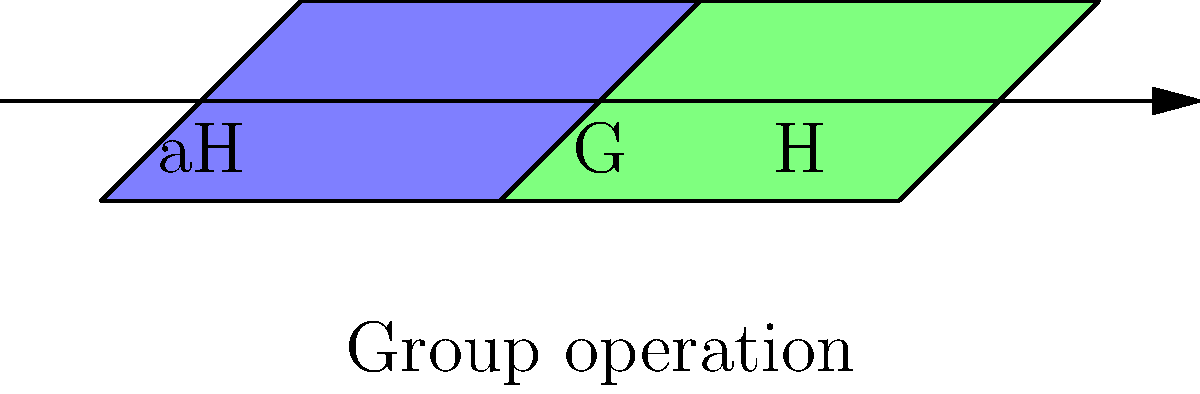In the context of group theory, consider a group $G$ represented by the entire diagram, with a subgroup $H$ (green region) and a coset $aH$ (blue region). How does this visual representation relate to the concept of cosets, and what implications does it have for understanding the structure of the group $G$? To understand the concept of cosets and its implications for the group structure, let's break it down step-by-step:

1. Group $G$: The entire diagram represents the group $G$, which contains all elements of the group.

2. Subgroup $H$: The green region represents a subgroup $H$ of $G$. A subgroup is a subset of $G$ that is itself a group under the same operation.

3. Coset $aH$: The blue region represents a left coset $aH$, where $a$ is an element of $G$ not in $H$.

4. Coset formation: The arrow labeled "Group operation" shows how the coset $aH$ is formed by applying the group operation between element $a$ and each element of $H$.

5. Partition: The diagram shows that $G$ is partitioned into distinct cosets. Each coset is a translation of $H$ within $G$.

6. Size of cosets: Both regions (green and blue) are the same size, illustrating that all cosets of a subgroup have the same number of elements as the subgroup itself.

7. Lagrange's Theorem: This visual representation supports Lagrange's Theorem, which states that the order of a subgroup $H$ divides the order of the group $G$.

8. Index: The number of distinct cosets is called the index of $H$ in $G$, denoted $[G:H]$. In this case, we can see two distinct regions, suggesting an index of 2.

9. Normal subgroups: If all left cosets of $H$ are also right cosets, then $H$ is a normal subgroup. This diagram doesn't provide enough information to determine normality.

10. Group structure: The coset decomposition provides insights into the structure of $G$, showing how it can be broken down into equally-sized, non-overlapping subsets.

This visual representation helps in understanding the abstract concept of cosets by showing how they partition the larger group and preserve the size of the subgroup, which is crucial for analyzing group structures in political systems or organizational hierarchies.
Answer: Cosets partition $G$ into equal-sized subsets, revealing group structure. 